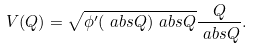Convert formula to latex. <formula><loc_0><loc_0><loc_500><loc_500>V ( Q ) & = \sqrt { \phi ^ { \prime } ( \ a b s { Q } ) \ a b s { Q } } \frac { Q } { \ a b s { Q } } .</formula> 